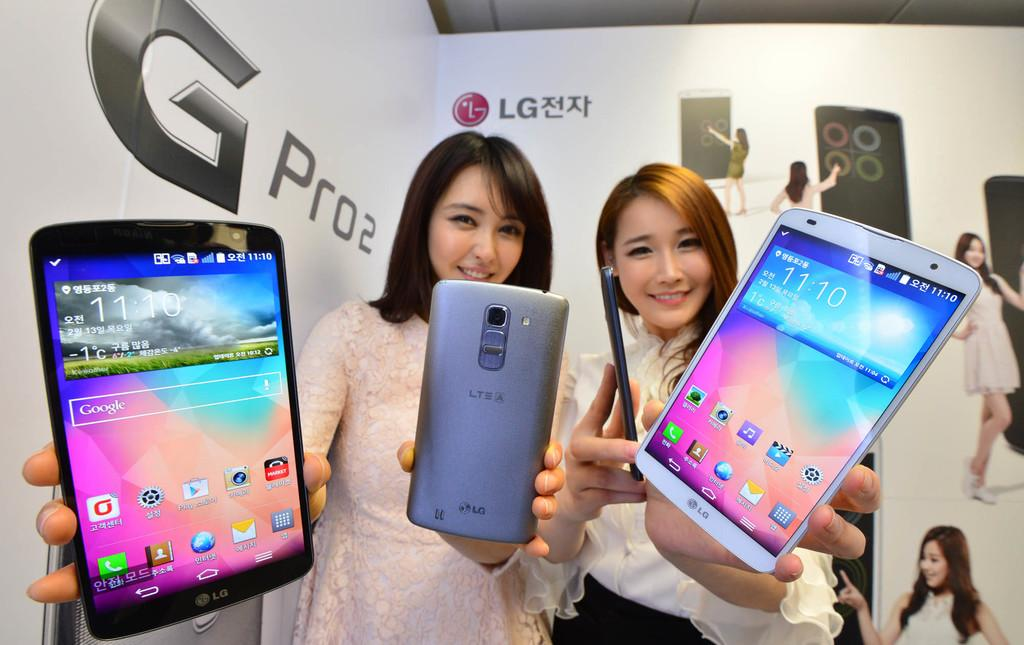How many people are present in the image? There are two girls in the image. What are the girls doing in the image? The girls are showing mobiles to the camera. What type of image is this? The image appears to be an advertisement. What can be seen in the background of the image? There is a big hoarding of a mobile company in the background of the image. What type of grass is growing on the limit in the image? There is no grass or limit present in the image. 